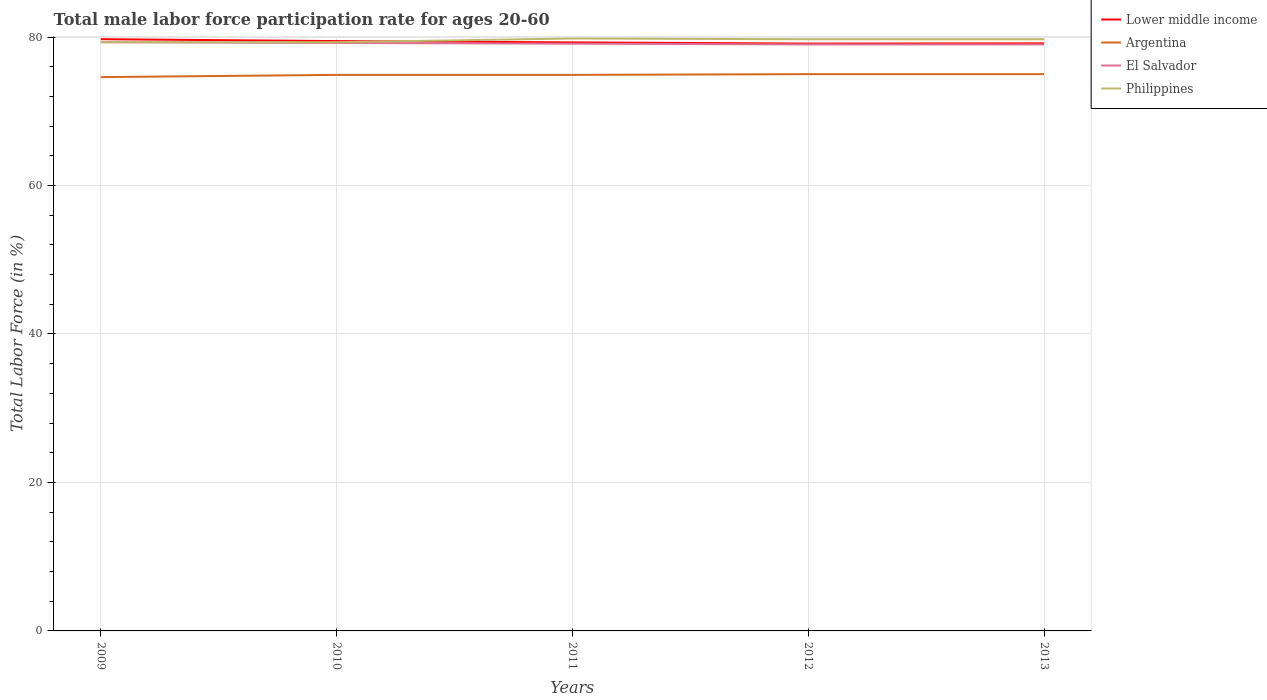Does the line corresponding to Lower middle income intersect with the line corresponding to Philippines?
Your answer should be very brief. Yes. Across all years, what is the maximum male labor force participation rate in Argentina?
Ensure brevity in your answer.  74.6. What is the total male labor force participation rate in Lower middle income in the graph?
Your response must be concise. 0.16. How many years are there in the graph?
Provide a short and direct response. 5. Are the values on the major ticks of Y-axis written in scientific E-notation?
Give a very brief answer. No. Does the graph contain any zero values?
Make the answer very short. No. Where does the legend appear in the graph?
Offer a very short reply. Top right. What is the title of the graph?
Your answer should be compact. Total male labor force participation rate for ages 20-60. What is the label or title of the Y-axis?
Offer a terse response. Total Labor Force (in %). What is the Total Labor Force (in %) in Lower middle income in 2009?
Your response must be concise. 79.71. What is the Total Labor Force (in %) of Argentina in 2009?
Your answer should be compact. 74.6. What is the Total Labor Force (in %) in El Salvador in 2009?
Your answer should be very brief. 79.3. What is the Total Labor Force (in %) in Philippines in 2009?
Keep it short and to the point. 79.3. What is the Total Labor Force (in %) of Lower middle income in 2010?
Your answer should be very brief. 79.45. What is the Total Labor Force (in %) in Argentina in 2010?
Your answer should be very brief. 74.9. What is the Total Labor Force (in %) in El Salvador in 2010?
Provide a succinct answer. 79.2. What is the Total Labor Force (in %) in Philippines in 2010?
Give a very brief answer. 79.3. What is the Total Labor Force (in %) of Lower middle income in 2011?
Your answer should be very brief. 79.28. What is the Total Labor Force (in %) of Argentina in 2011?
Ensure brevity in your answer.  74.9. What is the Total Labor Force (in %) in El Salvador in 2011?
Your response must be concise. 79.1. What is the Total Labor Force (in %) in Philippines in 2011?
Keep it short and to the point. 79.8. What is the Total Labor Force (in %) in Lower middle income in 2012?
Make the answer very short. 79.12. What is the Total Labor Force (in %) in Argentina in 2012?
Your answer should be compact. 75. What is the Total Labor Force (in %) in El Salvador in 2012?
Give a very brief answer. 79. What is the Total Labor Force (in %) of Philippines in 2012?
Give a very brief answer. 79.7. What is the Total Labor Force (in %) of Lower middle income in 2013?
Give a very brief answer. 79.15. What is the Total Labor Force (in %) of El Salvador in 2013?
Your response must be concise. 79. What is the Total Labor Force (in %) of Philippines in 2013?
Your answer should be very brief. 79.7. Across all years, what is the maximum Total Labor Force (in %) in Lower middle income?
Your answer should be compact. 79.71. Across all years, what is the maximum Total Labor Force (in %) in El Salvador?
Keep it short and to the point. 79.3. Across all years, what is the maximum Total Labor Force (in %) in Philippines?
Your response must be concise. 79.8. Across all years, what is the minimum Total Labor Force (in %) in Lower middle income?
Your answer should be compact. 79.12. Across all years, what is the minimum Total Labor Force (in %) in Argentina?
Your response must be concise. 74.6. Across all years, what is the minimum Total Labor Force (in %) of El Salvador?
Ensure brevity in your answer.  79. Across all years, what is the minimum Total Labor Force (in %) of Philippines?
Provide a short and direct response. 79.3. What is the total Total Labor Force (in %) in Lower middle income in the graph?
Provide a short and direct response. 396.7. What is the total Total Labor Force (in %) of Argentina in the graph?
Your answer should be very brief. 374.4. What is the total Total Labor Force (in %) of El Salvador in the graph?
Offer a terse response. 395.6. What is the total Total Labor Force (in %) of Philippines in the graph?
Keep it short and to the point. 397.8. What is the difference between the Total Labor Force (in %) of Lower middle income in 2009 and that in 2010?
Offer a terse response. 0.26. What is the difference between the Total Labor Force (in %) in Argentina in 2009 and that in 2010?
Your answer should be very brief. -0.3. What is the difference between the Total Labor Force (in %) in El Salvador in 2009 and that in 2010?
Provide a short and direct response. 0.1. What is the difference between the Total Labor Force (in %) of Philippines in 2009 and that in 2010?
Your response must be concise. 0. What is the difference between the Total Labor Force (in %) in Lower middle income in 2009 and that in 2011?
Give a very brief answer. 0.43. What is the difference between the Total Labor Force (in %) of Argentina in 2009 and that in 2011?
Give a very brief answer. -0.3. What is the difference between the Total Labor Force (in %) of Lower middle income in 2009 and that in 2012?
Your answer should be compact. 0.59. What is the difference between the Total Labor Force (in %) of Lower middle income in 2009 and that in 2013?
Give a very brief answer. 0.56. What is the difference between the Total Labor Force (in %) in Philippines in 2009 and that in 2013?
Your answer should be very brief. -0.4. What is the difference between the Total Labor Force (in %) of Lower middle income in 2010 and that in 2011?
Provide a short and direct response. 0.18. What is the difference between the Total Labor Force (in %) in Philippines in 2010 and that in 2011?
Provide a short and direct response. -0.5. What is the difference between the Total Labor Force (in %) of Lower middle income in 2010 and that in 2012?
Your answer should be very brief. 0.34. What is the difference between the Total Labor Force (in %) of El Salvador in 2010 and that in 2012?
Offer a very short reply. 0.2. What is the difference between the Total Labor Force (in %) in Lower middle income in 2010 and that in 2013?
Make the answer very short. 0.31. What is the difference between the Total Labor Force (in %) in El Salvador in 2010 and that in 2013?
Your response must be concise. 0.2. What is the difference between the Total Labor Force (in %) in Philippines in 2010 and that in 2013?
Provide a short and direct response. -0.4. What is the difference between the Total Labor Force (in %) in Lower middle income in 2011 and that in 2012?
Give a very brief answer. 0.16. What is the difference between the Total Labor Force (in %) in Argentina in 2011 and that in 2012?
Your response must be concise. -0.1. What is the difference between the Total Labor Force (in %) of El Salvador in 2011 and that in 2012?
Give a very brief answer. 0.1. What is the difference between the Total Labor Force (in %) of Philippines in 2011 and that in 2012?
Offer a very short reply. 0.1. What is the difference between the Total Labor Force (in %) in Lower middle income in 2011 and that in 2013?
Your answer should be compact. 0.13. What is the difference between the Total Labor Force (in %) in Argentina in 2011 and that in 2013?
Offer a terse response. -0.1. What is the difference between the Total Labor Force (in %) of El Salvador in 2011 and that in 2013?
Your answer should be compact. 0.1. What is the difference between the Total Labor Force (in %) of Lower middle income in 2012 and that in 2013?
Offer a terse response. -0.03. What is the difference between the Total Labor Force (in %) of Argentina in 2012 and that in 2013?
Ensure brevity in your answer.  0. What is the difference between the Total Labor Force (in %) of El Salvador in 2012 and that in 2013?
Your answer should be very brief. 0. What is the difference between the Total Labor Force (in %) of Philippines in 2012 and that in 2013?
Your answer should be very brief. 0. What is the difference between the Total Labor Force (in %) of Lower middle income in 2009 and the Total Labor Force (in %) of Argentina in 2010?
Your answer should be very brief. 4.81. What is the difference between the Total Labor Force (in %) of Lower middle income in 2009 and the Total Labor Force (in %) of El Salvador in 2010?
Your response must be concise. 0.51. What is the difference between the Total Labor Force (in %) in Lower middle income in 2009 and the Total Labor Force (in %) in Philippines in 2010?
Offer a terse response. 0.41. What is the difference between the Total Labor Force (in %) in Argentina in 2009 and the Total Labor Force (in %) in El Salvador in 2010?
Keep it short and to the point. -4.6. What is the difference between the Total Labor Force (in %) in Lower middle income in 2009 and the Total Labor Force (in %) in Argentina in 2011?
Make the answer very short. 4.81. What is the difference between the Total Labor Force (in %) of Lower middle income in 2009 and the Total Labor Force (in %) of El Salvador in 2011?
Ensure brevity in your answer.  0.61. What is the difference between the Total Labor Force (in %) of Lower middle income in 2009 and the Total Labor Force (in %) of Philippines in 2011?
Offer a very short reply. -0.09. What is the difference between the Total Labor Force (in %) of Argentina in 2009 and the Total Labor Force (in %) of Philippines in 2011?
Your answer should be very brief. -5.2. What is the difference between the Total Labor Force (in %) in Lower middle income in 2009 and the Total Labor Force (in %) in Argentina in 2012?
Provide a short and direct response. 4.71. What is the difference between the Total Labor Force (in %) in Lower middle income in 2009 and the Total Labor Force (in %) in El Salvador in 2012?
Provide a short and direct response. 0.71. What is the difference between the Total Labor Force (in %) of Lower middle income in 2009 and the Total Labor Force (in %) of Philippines in 2012?
Offer a terse response. 0.01. What is the difference between the Total Labor Force (in %) in Argentina in 2009 and the Total Labor Force (in %) in El Salvador in 2012?
Provide a short and direct response. -4.4. What is the difference between the Total Labor Force (in %) of Argentina in 2009 and the Total Labor Force (in %) of Philippines in 2012?
Make the answer very short. -5.1. What is the difference between the Total Labor Force (in %) of Lower middle income in 2009 and the Total Labor Force (in %) of Argentina in 2013?
Make the answer very short. 4.71. What is the difference between the Total Labor Force (in %) of Lower middle income in 2009 and the Total Labor Force (in %) of El Salvador in 2013?
Offer a terse response. 0.71. What is the difference between the Total Labor Force (in %) in Lower middle income in 2009 and the Total Labor Force (in %) in Philippines in 2013?
Provide a short and direct response. 0.01. What is the difference between the Total Labor Force (in %) of Argentina in 2009 and the Total Labor Force (in %) of El Salvador in 2013?
Offer a terse response. -4.4. What is the difference between the Total Labor Force (in %) in Argentina in 2009 and the Total Labor Force (in %) in Philippines in 2013?
Offer a very short reply. -5.1. What is the difference between the Total Labor Force (in %) in El Salvador in 2009 and the Total Labor Force (in %) in Philippines in 2013?
Offer a very short reply. -0.4. What is the difference between the Total Labor Force (in %) in Lower middle income in 2010 and the Total Labor Force (in %) in Argentina in 2011?
Ensure brevity in your answer.  4.55. What is the difference between the Total Labor Force (in %) of Lower middle income in 2010 and the Total Labor Force (in %) of El Salvador in 2011?
Keep it short and to the point. 0.35. What is the difference between the Total Labor Force (in %) of Lower middle income in 2010 and the Total Labor Force (in %) of Philippines in 2011?
Ensure brevity in your answer.  -0.35. What is the difference between the Total Labor Force (in %) in Argentina in 2010 and the Total Labor Force (in %) in El Salvador in 2011?
Provide a succinct answer. -4.2. What is the difference between the Total Labor Force (in %) of Lower middle income in 2010 and the Total Labor Force (in %) of Argentina in 2012?
Your answer should be very brief. 4.45. What is the difference between the Total Labor Force (in %) of Lower middle income in 2010 and the Total Labor Force (in %) of El Salvador in 2012?
Your answer should be compact. 0.45. What is the difference between the Total Labor Force (in %) in Lower middle income in 2010 and the Total Labor Force (in %) in Philippines in 2012?
Offer a terse response. -0.25. What is the difference between the Total Labor Force (in %) of Argentina in 2010 and the Total Labor Force (in %) of Philippines in 2012?
Your response must be concise. -4.8. What is the difference between the Total Labor Force (in %) in El Salvador in 2010 and the Total Labor Force (in %) in Philippines in 2012?
Provide a succinct answer. -0.5. What is the difference between the Total Labor Force (in %) of Lower middle income in 2010 and the Total Labor Force (in %) of Argentina in 2013?
Keep it short and to the point. 4.45. What is the difference between the Total Labor Force (in %) in Lower middle income in 2010 and the Total Labor Force (in %) in El Salvador in 2013?
Your answer should be compact. 0.45. What is the difference between the Total Labor Force (in %) of Lower middle income in 2010 and the Total Labor Force (in %) of Philippines in 2013?
Keep it short and to the point. -0.25. What is the difference between the Total Labor Force (in %) of Argentina in 2010 and the Total Labor Force (in %) of El Salvador in 2013?
Your answer should be compact. -4.1. What is the difference between the Total Labor Force (in %) of Argentina in 2010 and the Total Labor Force (in %) of Philippines in 2013?
Make the answer very short. -4.8. What is the difference between the Total Labor Force (in %) in Lower middle income in 2011 and the Total Labor Force (in %) in Argentina in 2012?
Your answer should be very brief. 4.28. What is the difference between the Total Labor Force (in %) in Lower middle income in 2011 and the Total Labor Force (in %) in El Salvador in 2012?
Your answer should be very brief. 0.28. What is the difference between the Total Labor Force (in %) in Lower middle income in 2011 and the Total Labor Force (in %) in Philippines in 2012?
Offer a very short reply. -0.42. What is the difference between the Total Labor Force (in %) of Argentina in 2011 and the Total Labor Force (in %) of El Salvador in 2012?
Ensure brevity in your answer.  -4.1. What is the difference between the Total Labor Force (in %) in Lower middle income in 2011 and the Total Labor Force (in %) in Argentina in 2013?
Your response must be concise. 4.28. What is the difference between the Total Labor Force (in %) in Lower middle income in 2011 and the Total Labor Force (in %) in El Salvador in 2013?
Provide a succinct answer. 0.28. What is the difference between the Total Labor Force (in %) of Lower middle income in 2011 and the Total Labor Force (in %) of Philippines in 2013?
Offer a terse response. -0.42. What is the difference between the Total Labor Force (in %) of Argentina in 2011 and the Total Labor Force (in %) of El Salvador in 2013?
Make the answer very short. -4.1. What is the difference between the Total Labor Force (in %) in Lower middle income in 2012 and the Total Labor Force (in %) in Argentina in 2013?
Offer a terse response. 4.12. What is the difference between the Total Labor Force (in %) of Lower middle income in 2012 and the Total Labor Force (in %) of El Salvador in 2013?
Offer a terse response. 0.12. What is the difference between the Total Labor Force (in %) of Lower middle income in 2012 and the Total Labor Force (in %) of Philippines in 2013?
Your answer should be very brief. -0.58. What is the difference between the Total Labor Force (in %) of Argentina in 2012 and the Total Labor Force (in %) of Philippines in 2013?
Your answer should be very brief. -4.7. What is the average Total Labor Force (in %) in Lower middle income per year?
Ensure brevity in your answer.  79.34. What is the average Total Labor Force (in %) of Argentina per year?
Provide a succinct answer. 74.88. What is the average Total Labor Force (in %) of El Salvador per year?
Offer a very short reply. 79.12. What is the average Total Labor Force (in %) of Philippines per year?
Ensure brevity in your answer.  79.56. In the year 2009, what is the difference between the Total Labor Force (in %) in Lower middle income and Total Labor Force (in %) in Argentina?
Your answer should be compact. 5.11. In the year 2009, what is the difference between the Total Labor Force (in %) in Lower middle income and Total Labor Force (in %) in El Salvador?
Give a very brief answer. 0.41. In the year 2009, what is the difference between the Total Labor Force (in %) of Lower middle income and Total Labor Force (in %) of Philippines?
Offer a terse response. 0.41. In the year 2010, what is the difference between the Total Labor Force (in %) in Lower middle income and Total Labor Force (in %) in Argentina?
Provide a succinct answer. 4.55. In the year 2010, what is the difference between the Total Labor Force (in %) of Lower middle income and Total Labor Force (in %) of El Salvador?
Offer a terse response. 0.25. In the year 2010, what is the difference between the Total Labor Force (in %) in Lower middle income and Total Labor Force (in %) in Philippines?
Make the answer very short. 0.15. In the year 2011, what is the difference between the Total Labor Force (in %) of Lower middle income and Total Labor Force (in %) of Argentina?
Provide a short and direct response. 4.38. In the year 2011, what is the difference between the Total Labor Force (in %) in Lower middle income and Total Labor Force (in %) in El Salvador?
Provide a succinct answer. 0.18. In the year 2011, what is the difference between the Total Labor Force (in %) in Lower middle income and Total Labor Force (in %) in Philippines?
Ensure brevity in your answer.  -0.52. In the year 2011, what is the difference between the Total Labor Force (in %) in El Salvador and Total Labor Force (in %) in Philippines?
Make the answer very short. -0.7. In the year 2012, what is the difference between the Total Labor Force (in %) of Lower middle income and Total Labor Force (in %) of Argentina?
Keep it short and to the point. 4.12. In the year 2012, what is the difference between the Total Labor Force (in %) in Lower middle income and Total Labor Force (in %) in El Salvador?
Provide a short and direct response. 0.12. In the year 2012, what is the difference between the Total Labor Force (in %) of Lower middle income and Total Labor Force (in %) of Philippines?
Your response must be concise. -0.58. In the year 2012, what is the difference between the Total Labor Force (in %) of Argentina and Total Labor Force (in %) of El Salvador?
Offer a very short reply. -4. In the year 2012, what is the difference between the Total Labor Force (in %) in Argentina and Total Labor Force (in %) in Philippines?
Offer a terse response. -4.7. In the year 2013, what is the difference between the Total Labor Force (in %) in Lower middle income and Total Labor Force (in %) in Argentina?
Provide a succinct answer. 4.15. In the year 2013, what is the difference between the Total Labor Force (in %) in Lower middle income and Total Labor Force (in %) in El Salvador?
Your response must be concise. 0.15. In the year 2013, what is the difference between the Total Labor Force (in %) of Lower middle income and Total Labor Force (in %) of Philippines?
Your answer should be very brief. -0.55. In the year 2013, what is the difference between the Total Labor Force (in %) of Argentina and Total Labor Force (in %) of Philippines?
Keep it short and to the point. -4.7. What is the ratio of the Total Labor Force (in %) of Lower middle income in 2009 to that in 2010?
Offer a very short reply. 1. What is the ratio of the Total Labor Force (in %) in El Salvador in 2009 to that in 2010?
Offer a very short reply. 1. What is the ratio of the Total Labor Force (in %) in Lower middle income in 2009 to that in 2011?
Your answer should be compact. 1.01. What is the ratio of the Total Labor Force (in %) in Argentina in 2009 to that in 2011?
Give a very brief answer. 1. What is the ratio of the Total Labor Force (in %) in El Salvador in 2009 to that in 2011?
Keep it short and to the point. 1. What is the ratio of the Total Labor Force (in %) of Philippines in 2009 to that in 2011?
Ensure brevity in your answer.  0.99. What is the ratio of the Total Labor Force (in %) in Lower middle income in 2009 to that in 2012?
Make the answer very short. 1.01. What is the ratio of the Total Labor Force (in %) of Lower middle income in 2009 to that in 2013?
Your answer should be compact. 1.01. What is the ratio of the Total Labor Force (in %) in El Salvador in 2009 to that in 2013?
Give a very brief answer. 1. What is the ratio of the Total Labor Force (in %) of Lower middle income in 2010 to that in 2011?
Make the answer very short. 1. What is the ratio of the Total Labor Force (in %) in Philippines in 2010 to that in 2011?
Offer a terse response. 0.99. What is the ratio of the Total Labor Force (in %) of Lower middle income in 2010 to that in 2012?
Your answer should be compact. 1. What is the ratio of the Total Labor Force (in %) in El Salvador in 2010 to that in 2012?
Give a very brief answer. 1. What is the ratio of the Total Labor Force (in %) in Lower middle income in 2010 to that in 2013?
Offer a very short reply. 1. What is the ratio of the Total Labor Force (in %) in El Salvador in 2011 to that in 2012?
Your answer should be compact. 1. What is the ratio of the Total Labor Force (in %) in Philippines in 2011 to that in 2012?
Ensure brevity in your answer.  1. What is the ratio of the Total Labor Force (in %) of Argentina in 2011 to that in 2013?
Provide a short and direct response. 1. What is the ratio of the Total Labor Force (in %) in El Salvador in 2011 to that in 2013?
Provide a short and direct response. 1. What is the ratio of the Total Labor Force (in %) of Philippines in 2011 to that in 2013?
Your answer should be compact. 1. What is the ratio of the Total Labor Force (in %) in Argentina in 2012 to that in 2013?
Your answer should be very brief. 1. What is the ratio of the Total Labor Force (in %) of El Salvador in 2012 to that in 2013?
Your answer should be compact. 1. What is the difference between the highest and the second highest Total Labor Force (in %) in Lower middle income?
Give a very brief answer. 0.26. What is the difference between the highest and the second highest Total Labor Force (in %) of Argentina?
Provide a short and direct response. 0. What is the difference between the highest and the second highest Total Labor Force (in %) in Philippines?
Your response must be concise. 0.1. What is the difference between the highest and the lowest Total Labor Force (in %) in Lower middle income?
Offer a terse response. 0.59. What is the difference between the highest and the lowest Total Labor Force (in %) of El Salvador?
Offer a very short reply. 0.3. What is the difference between the highest and the lowest Total Labor Force (in %) of Philippines?
Provide a succinct answer. 0.5. 